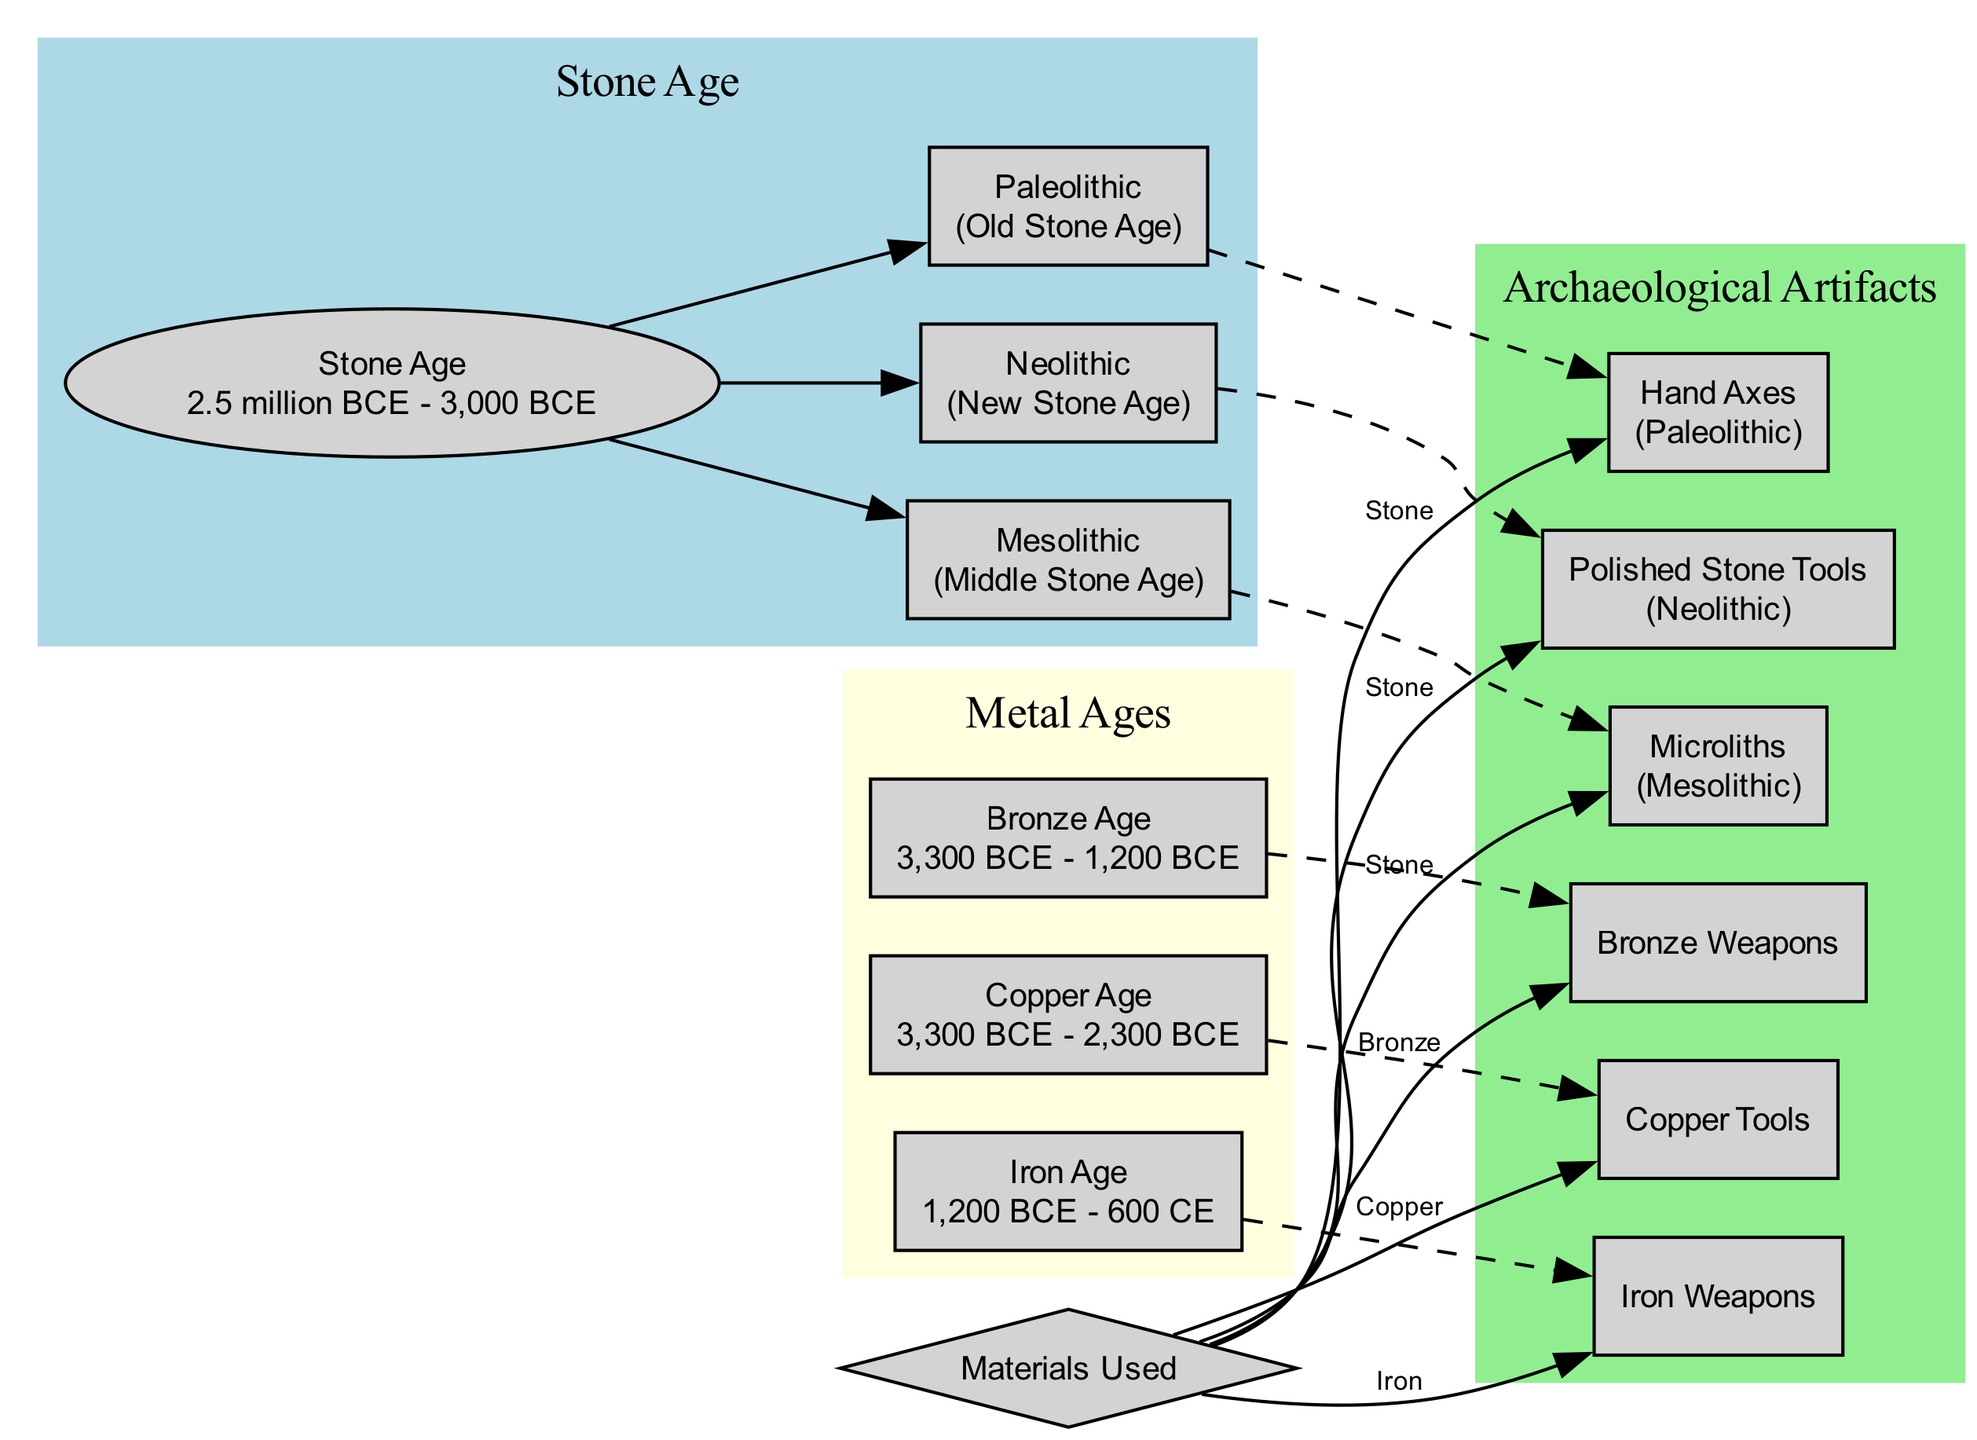What is the time period of the Stone Age? The diagram indicates that the Stone Age lasted from 2.5 million BCE to 3,000 BCE, as stated in the description of the Stone Age node.
Answer: 2.5 million BCE - 3,000 BCE Which tools are associated with the Paleolithic era? According to the diagram, the Paleolithic era is associated with Hand Axes, as indicated in the connection between the Paleolithic and Hand Axes nodes.
Answer: Hand Axes How many epochs are included in the Stone Age? The diagram shows that the Stone Age includes three epochs: Paleolithic, Mesolithic, and Neolithic, which can be counted in the edges connecting to the Stone Age node.
Answer: 3 What materials are used for Iron Weapons? The materials used for Iron Weapons are specified as Iron in the edge connecting the materials node to the Iron Weapons node.
Answer: Iron What is the relationship between the Copper Age and Copper Tools? The diagram indicates that the Copper Age contains Copper Tools as shown by the dashed edge connecting the Copper Age node to the Copper Tools node.
Answer: contains Name one tool from the Neolithic age. The diagram lists Polished Stone Tools as the tool belonging to the Neolithic age, which can be seen in the connection from the Neolithic node.
Answer: Polished Stone Tools Which age comes after the Bronze Age? The diagram indicates that the Iron Age follows the Bronze Age, visible in the sequential arrangement of the nodes in the 'Metal Ages' section.
Answer: Iron Age What type of artifacts is shown in the Archaeological Artifacts section? The Archaeological Artifacts section shows various tools, such as Hand Axes, Microliths, Polished Stone Tools, Copper Tools, Bronze Weapons, and Iron Weapons, as listed in the respective nodes.
Answer: Tools What is the main material used for tools in the Mesolithic age? The diagram shows that the main material used for tools in the Mesolithic age (Microliths) is Stone, as indicated by the connection from the materials node to the Microliths node.
Answer: Stone 